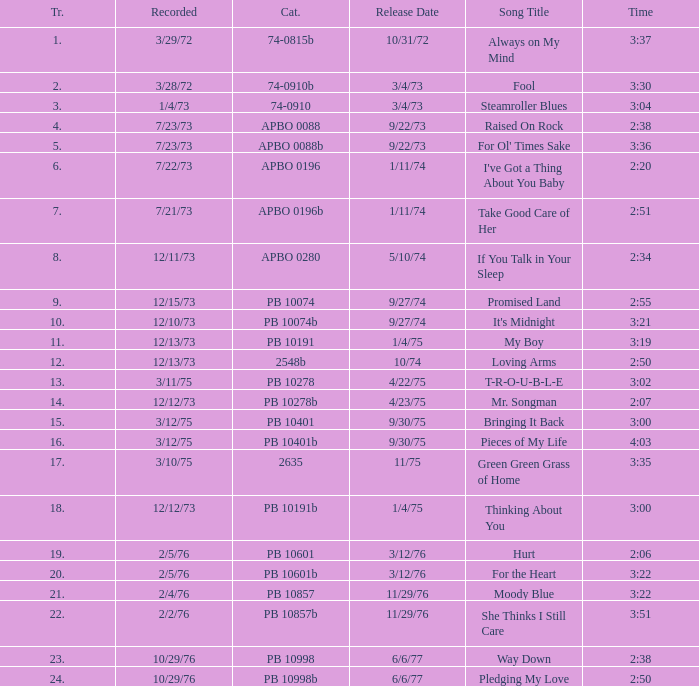I want the sum of tracks for raised on rock 4.0. Can you give me this table as a dict? {'header': ['Tr.', 'Recorded', 'Cat.', 'Release Date', 'Song Title', 'Time'], 'rows': [['1.', '3/29/72', '74-0815b', '10/31/72', 'Always on My Mind', '3:37'], ['2.', '3/28/72', '74-0910b', '3/4/73', 'Fool', '3:30'], ['3.', '1/4/73', '74-0910', '3/4/73', 'Steamroller Blues', '3:04'], ['4.', '7/23/73', 'APBO 0088', '9/22/73', 'Raised On Rock', '2:38'], ['5.', '7/23/73', 'APBO 0088b', '9/22/73', "For Ol' Times Sake", '3:36'], ['6.', '7/22/73', 'APBO 0196', '1/11/74', "I've Got a Thing About You Baby", '2:20'], ['7.', '7/21/73', 'APBO 0196b', '1/11/74', 'Take Good Care of Her', '2:51'], ['8.', '12/11/73', 'APBO 0280', '5/10/74', 'If You Talk in Your Sleep', '2:34'], ['9.', '12/15/73', 'PB 10074', '9/27/74', 'Promised Land', '2:55'], ['10.', '12/10/73', 'PB 10074b', '9/27/74', "It's Midnight", '3:21'], ['11.', '12/13/73', 'PB 10191', '1/4/75', 'My Boy', '3:19'], ['12.', '12/13/73', '2548b', '10/74', 'Loving Arms', '2:50'], ['13.', '3/11/75', 'PB 10278', '4/22/75', 'T-R-O-U-B-L-E', '3:02'], ['14.', '12/12/73', 'PB 10278b', '4/23/75', 'Mr. Songman', '2:07'], ['15.', '3/12/75', 'PB 10401', '9/30/75', 'Bringing It Back', '3:00'], ['16.', '3/12/75', 'PB 10401b', '9/30/75', 'Pieces of My Life', '4:03'], ['17.', '3/10/75', '2635', '11/75', 'Green Green Grass of Home', '3:35'], ['18.', '12/12/73', 'PB 10191b', '1/4/75', 'Thinking About You', '3:00'], ['19.', '2/5/76', 'PB 10601', '3/12/76', 'Hurt', '2:06'], ['20.', '2/5/76', 'PB 10601b', '3/12/76', 'For the Heart', '3:22'], ['21.', '2/4/76', 'PB 10857', '11/29/76', 'Moody Blue', '3:22'], ['22.', '2/2/76', 'PB 10857b', '11/29/76', 'She Thinks I Still Care', '3:51'], ['23.', '10/29/76', 'PB 10998', '6/6/77', 'Way Down', '2:38'], ['24.', '10/29/76', 'PB 10998b', '6/6/77', 'Pledging My Love', '2:50']]} 